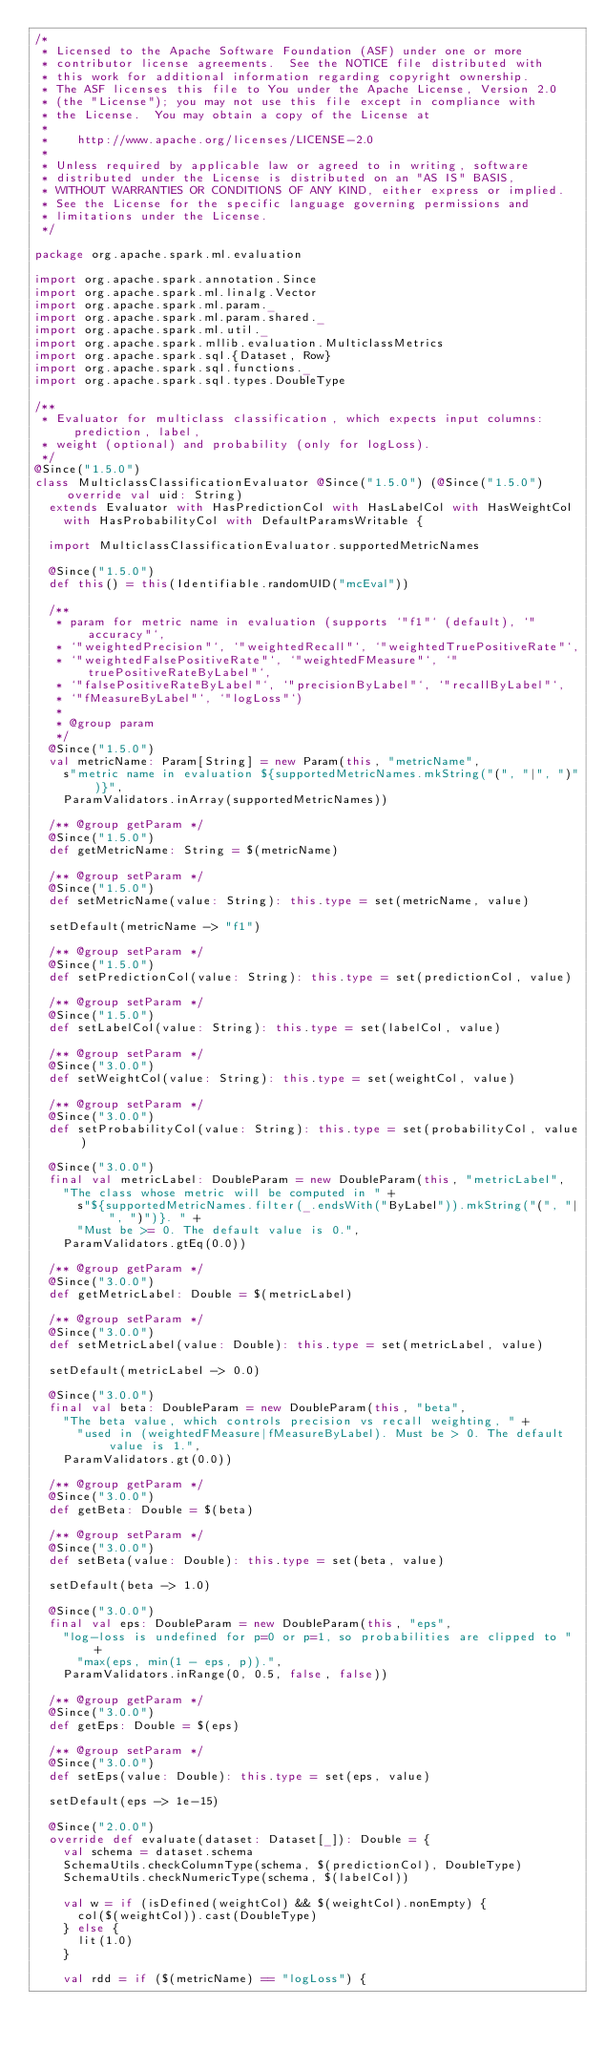Convert code to text. <code><loc_0><loc_0><loc_500><loc_500><_Scala_>/*
 * Licensed to the Apache Software Foundation (ASF) under one or more
 * contributor license agreements.  See the NOTICE file distributed with
 * this work for additional information regarding copyright ownership.
 * The ASF licenses this file to You under the Apache License, Version 2.0
 * (the "License"); you may not use this file except in compliance with
 * the License.  You may obtain a copy of the License at
 *
 *    http://www.apache.org/licenses/LICENSE-2.0
 *
 * Unless required by applicable law or agreed to in writing, software
 * distributed under the License is distributed on an "AS IS" BASIS,
 * WITHOUT WARRANTIES OR CONDITIONS OF ANY KIND, either express or implied.
 * See the License for the specific language governing permissions and
 * limitations under the License.
 */

package org.apache.spark.ml.evaluation

import org.apache.spark.annotation.Since
import org.apache.spark.ml.linalg.Vector
import org.apache.spark.ml.param._
import org.apache.spark.ml.param.shared._
import org.apache.spark.ml.util._
import org.apache.spark.mllib.evaluation.MulticlassMetrics
import org.apache.spark.sql.{Dataset, Row}
import org.apache.spark.sql.functions._
import org.apache.spark.sql.types.DoubleType

/**
 * Evaluator for multiclass classification, which expects input columns: prediction, label,
 * weight (optional) and probability (only for logLoss).
 */
@Since("1.5.0")
class MulticlassClassificationEvaluator @Since("1.5.0") (@Since("1.5.0") override val uid: String)
  extends Evaluator with HasPredictionCol with HasLabelCol with HasWeightCol
    with HasProbabilityCol with DefaultParamsWritable {

  import MulticlassClassificationEvaluator.supportedMetricNames

  @Since("1.5.0")
  def this() = this(Identifiable.randomUID("mcEval"))

  /**
   * param for metric name in evaluation (supports `"f1"` (default), `"accuracy"`,
   * `"weightedPrecision"`, `"weightedRecall"`, `"weightedTruePositiveRate"`,
   * `"weightedFalsePositiveRate"`, `"weightedFMeasure"`, `"truePositiveRateByLabel"`,
   * `"falsePositiveRateByLabel"`, `"precisionByLabel"`, `"recallByLabel"`,
   * `"fMeasureByLabel"`, `"logLoss"`)
   *
   * @group param
   */
  @Since("1.5.0")
  val metricName: Param[String] = new Param(this, "metricName",
    s"metric name in evaluation ${supportedMetricNames.mkString("(", "|", ")")}",
    ParamValidators.inArray(supportedMetricNames))

  /** @group getParam */
  @Since("1.5.0")
  def getMetricName: String = $(metricName)

  /** @group setParam */
  @Since("1.5.0")
  def setMetricName(value: String): this.type = set(metricName, value)

  setDefault(metricName -> "f1")

  /** @group setParam */
  @Since("1.5.0")
  def setPredictionCol(value: String): this.type = set(predictionCol, value)

  /** @group setParam */
  @Since("1.5.0")
  def setLabelCol(value: String): this.type = set(labelCol, value)

  /** @group setParam */
  @Since("3.0.0")
  def setWeightCol(value: String): this.type = set(weightCol, value)

  /** @group setParam */
  @Since("3.0.0")
  def setProbabilityCol(value: String): this.type = set(probabilityCol, value)

  @Since("3.0.0")
  final val metricLabel: DoubleParam = new DoubleParam(this, "metricLabel",
    "The class whose metric will be computed in " +
      s"${supportedMetricNames.filter(_.endsWith("ByLabel")).mkString("(", "|", ")")}. " +
      "Must be >= 0. The default value is 0.",
    ParamValidators.gtEq(0.0))

  /** @group getParam */
  @Since("3.0.0")
  def getMetricLabel: Double = $(metricLabel)

  /** @group setParam */
  @Since("3.0.0")
  def setMetricLabel(value: Double): this.type = set(metricLabel, value)

  setDefault(metricLabel -> 0.0)

  @Since("3.0.0")
  final val beta: DoubleParam = new DoubleParam(this, "beta",
    "The beta value, which controls precision vs recall weighting, " +
      "used in (weightedFMeasure|fMeasureByLabel). Must be > 0. The default value is 1.",
    ParamValidators.gt(0.0))

  /** @group getParam */
  @Since("3.0.0")
  def getBeta: Double = $(beta)

  /** @group setParam */
  @Since("3.0.0")
  def setBeta(value: Double): this.type = set(beta, value)

  setDefault(beta -> 1.0)

  @Since("3.0.0")
  final val eps: DoubleParam = new DoubleParam(this, "eps",
    "log-loss is undefined for p=0 or p=1, so probabilities are clipped to " +
      "max(eps, min(1 - eps, p)).",
    ParamValidators.inRange(0, 0.5, false, false))

  /** @group getParam */
  @Since("3.0.0")
  def getEps: Double = $(eps)

  /** @group setParam */
  @Since("3.0.0")
  def setEps(value: Double): this.type = set(eps, value)

  setDefault(eps -> 1e-15)

  @Since("2.0.0")
  override def evaluate(dataset: Dataset[_]): Double = {
    val schema = dataset.schema
    SchemaUtils.checkColumnType(schema, $(predictionCol), DoubleType)
    SchemaUtils.checkNumericType(schema, $(labelCol))

    val w = if (isDefined(weightCol) && $(weightCol).nonEmpty) {
      col($(weightCol)).cast(DoubleType)
    } else {
      lit(1.0)
    }

    val rdd = if ($(metricName) == "logLoss") {</code> 